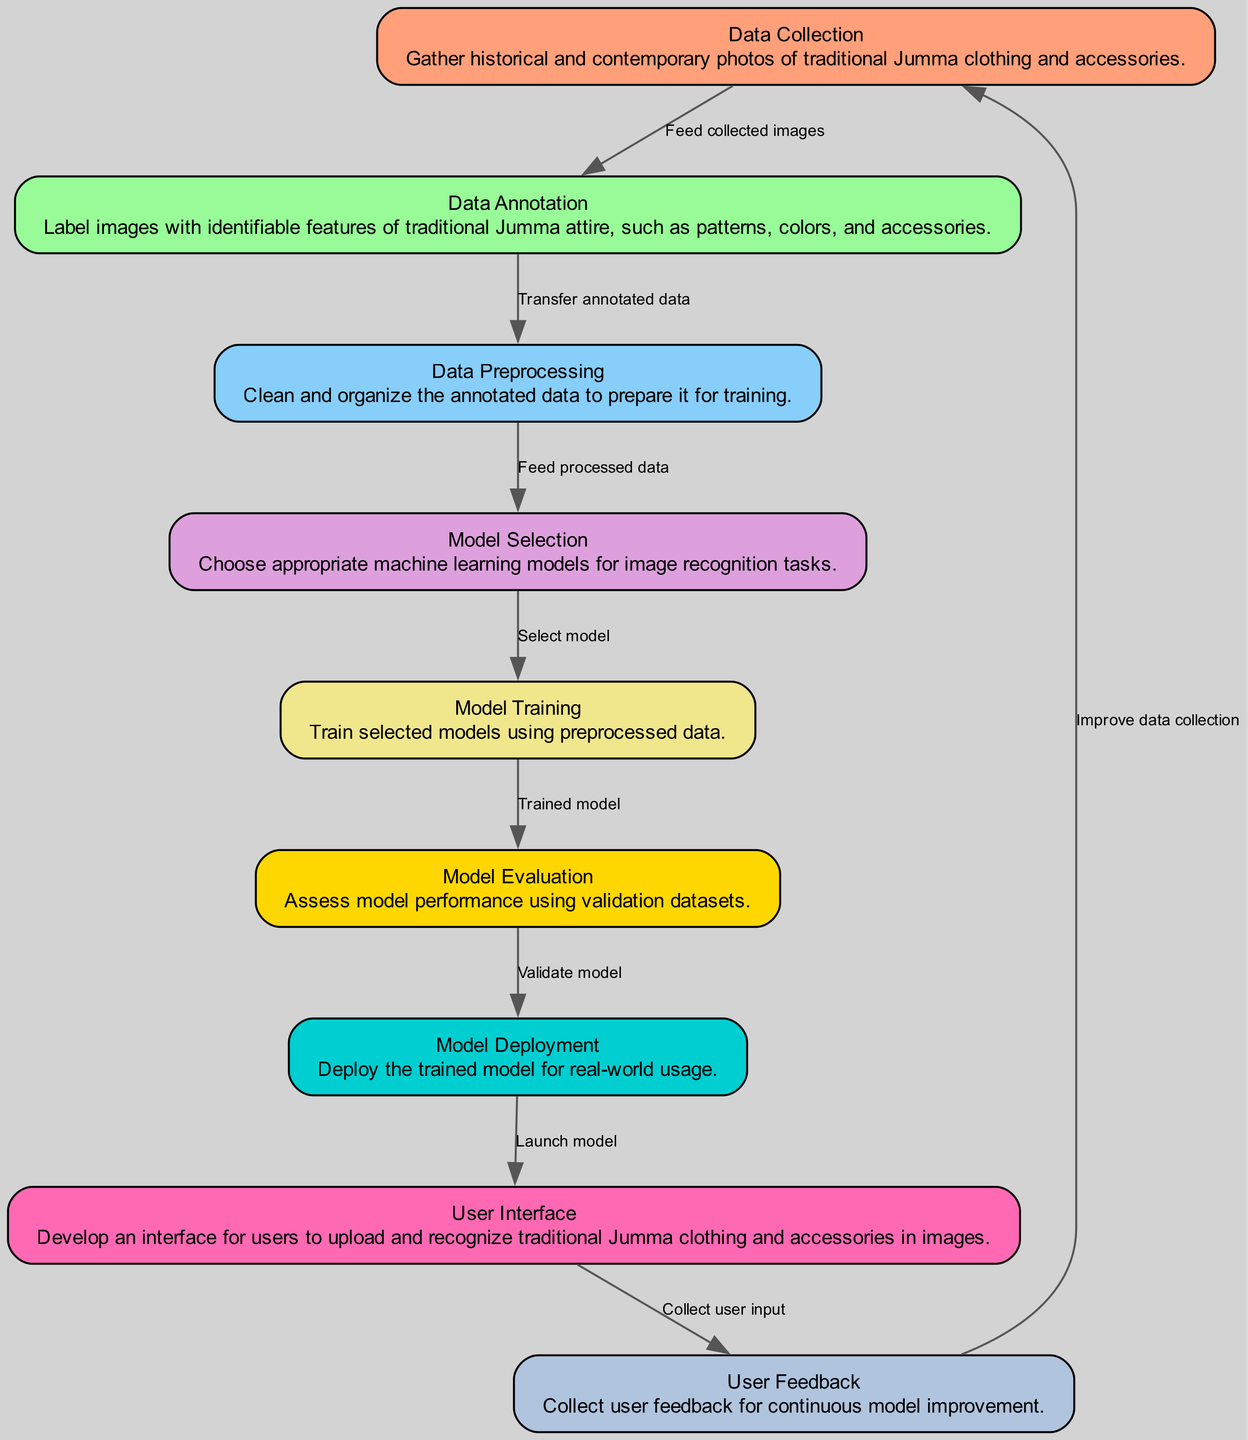What is the first step in the diagram? The first step in the diagram is 'Data Collection,' where historical and contemporary photos are gathered.
Answer: Data Collection How many edges are there in the diagram? Counting the connections between the nodes, there are 9 edges that show the flow from one process to another.
Answer: 9 What do you obtain after 'User Interface'? After 'User Interface', the output process is 'Feedback', where user input is collected for continuous improvement of the model.
Answer: Feedback Which node involves model performance assessment? The node responsible for assessing model performance is ‘Model Evaluation’. It validates the trained model using validation datasets.
Answer: Model Evaluation What do you feed into 'Model Selection'? The input for 'Model Selection' is the 'Processed Data', which consists of the cleaned and organized data after preprocessing.
Answer: Processed Data Which node follows 'Training'? The node that follows 'Training' is 'Model Evaluation', where the trained model is assessed for its performance.
Answer: Model Evaluation What color represents 'User Interface' in the diagram? The color representing 'User Interface' is Hot Pink, which is used to signify this particular step visually in the diagram.
Answer: Hot Pink What is the purpose of 'Data Annotation'? 'Data Annotation' is used to label images with identifiable features such as patterns, colors, and accessories of traditional Jumma attire.
Answer: Label images Which step comes before 'Model Deployment'? The step that comes before 'Model Deployment' is 'Model Evaluation', which ensures the model is validated before deployment for real-world use.
Answer: Model Evaluation How is user feedback utilized in the process? User feedback is collected to improve the 'Data Collection' process, allowing the model to be refined and enhanced over time.
Answer: Improve data collection 